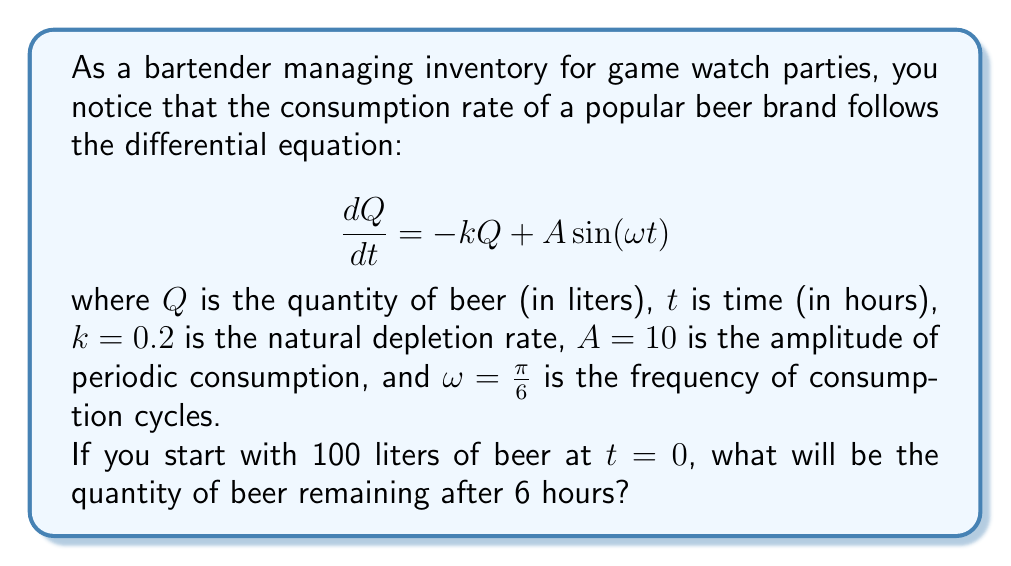Provide a solution to this math problem. To solve this problem, we need to find the general solution to the given differential equation and then apply the initial condition.

1. The general solution to this differential equation is of the form:

   $$Q(t) = Q_h + Q_p$$

   where $Q_h$ is the homogeneous solution and $Q_p$ is the particular solution.

2. The homogeneous solution is:

   $$Q_h = Ce^{-kt} = Ce^{-0.2t}$$

3. For the particular solution, we assume the form:

   $$Q_p = M\cos(\omega t) + N\sin(\omega t)$$

4. Substituting this into the original equation and solving for M and N:

   $$M = \frac{-A\omega}{k^2 + \omega^2} = \frac{-10(\pi/6)}{0.2^2 + (\pi/6)^2} \approx -8.2415$$
   $$N = \frac{Ak}{k^2 + \omega^2} = \frac{10(0.2)}{0.2^2 + (\pi/6)^2} \approx 9.8039$$

5. The general solution is:

   $$Q(t) = Ce^{-0.2t} - 8.2415\cos(\frac{\pi}{6}t) + 9.8039\sin(\frac{\pi}{6}t)$$

6. Apply the initial condition $Q(0) = 100$:

   $$100 = C - 8.2415$$
   $$C = 108.2415$$

7. The final solution is:

   $$Q(t) = 108.2415e^{-0.2t} - 8.2415\cos(\frac{\pi}{6}t) + 9.8039\sin(\frac{\pi}{6}t)$$

8. To find the quantity after 6 hours, substitute $t = 6$:

   $$Q(6) = 108.2415e^{-1.2} - 8.2415\cos(\pi) + 9.8039\sin(\pi)$$
   $$Q(6) = 108.2415(0.3012) + 8.2415 + 0$$
   $$Q(6) = 32.6023 + 8.2415 = 40.8438$$
Answer: The quantity of beer remaining after 6 hours is approximately 40.84 liters. 